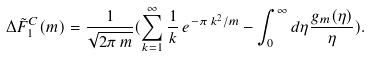<formula> <loc_0><loc_0><loc_500><loc_500>\Delta \tilde { F } ^ { C } _ { 1 } ( m ) = \frac { 1 } { \sqrt { 2 \pi \, m } } ( \sum _ { k = 1 } ^ { \infty } \frac { 1 } { k } \, e ^ { - \pi \, k ^ { 2 } / m } - \int _ { 0 } ^ { \infty } d \eta \frac { g _ { m } ( \eta ) } { \eta } ) .</formula> 